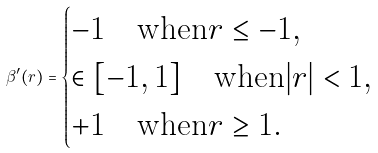<formula> <loc_0><loc_0><loc_500><loc_500>\beta ^ { \prime } ( r ) = \begin{cases} - 1 \quad \text {when} r \leq - 1 , \\ \in [ - 1 , 1 ] \quad \text {when} | r | < 1 , \\ + 1 \quad \text {when} r \geq 1 . \end{cases}</formula> 